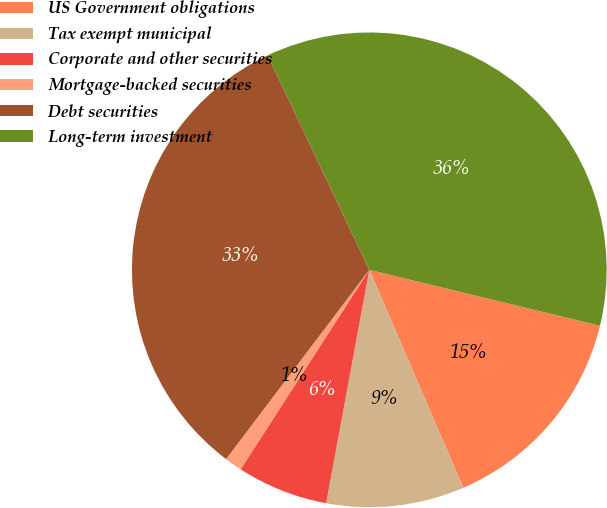<chart> <loc_0><loc_0><loc_500><loc_500><pie_chart><fcel>US Government obligations<fcel>Tax exempt municipal<fcel>Corporate and other securities<fcel>Mortgage-backed securities<fcel>Debt securities<fcel>Long-term investment<nl><fcel>14.73%<fcel>9.39%<fcel>6.21%<fcel>1.19%<fcel>32.64%<fcel>35.83%<nl></chart> 